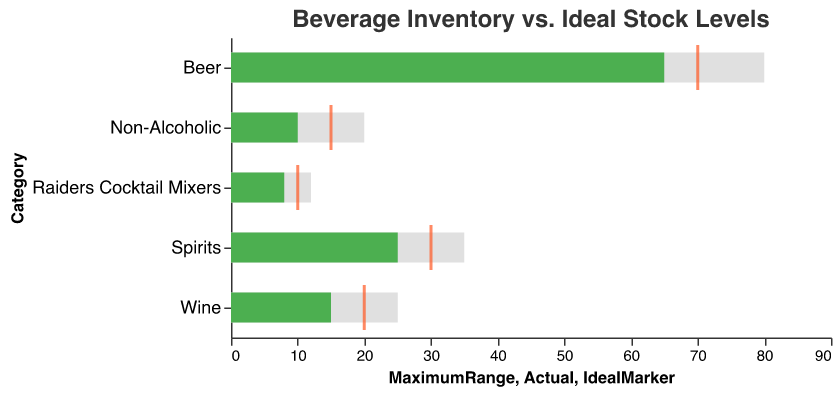What are the beverage categories listed in the chart? The chart lists the different categories of beverages including Beer, Wine, Spirits, Non-Alcoholic, and Raiders Cocktail Mixers.
Answer: Beer, Wine, Spirits, Non-Alcoholic, Raiders Cocktail Mixers What is the title of the chart? The title is located at the top of the chart and reads "Beverage Inventory vs. Ideal Stock Levels".
Answer: Beverage Inventory vs. Ideal Stock Levels What color represents the 'Actual' stock levels in the chart? The 'Actual' stock levels are represented by green bars in the chart.
Answer: Green What is the ideal stock level for Non-Alcoholic beverages? The ideal stock level for Non-Alcoholic beverages is indicated by an orange tick mark positioned at the value of 15.
Answer: 15 How do the actual stock levels of Wine compare to their ideal stock levels? The actual stock levels of Wine are 15 units, which are 5 units lower than the ideal stock levels of 20.
Answer: 5 units lower Which category has the largest gap between their actual and maximum stock levels? The Beer category has an actual stock level of 65 and a maximum stock level of 80, resulting in a gap of 15 units.
Answer: Beer How much more inventory is needed for Spirits to reach its ideal stock level? The actual stock level for Spirits is 25, and the ideal stock level is 30. The difference needed to reach the ideal is 5 units.
Answer: 5 units If you sum up the actual stock levels of Wine and Non-Alcoholic beverages, what do you get? The actual stock level for Wine is 15 and for Non-Alcoholic is 10. Adding them together yields 15 + 10 = 25.
Answer: 25 Which category meets its maximum stock level? By comparing the bars to their respective maximum ticks for each category, none of the categories meet their maximum stock levels.
Answer: None 